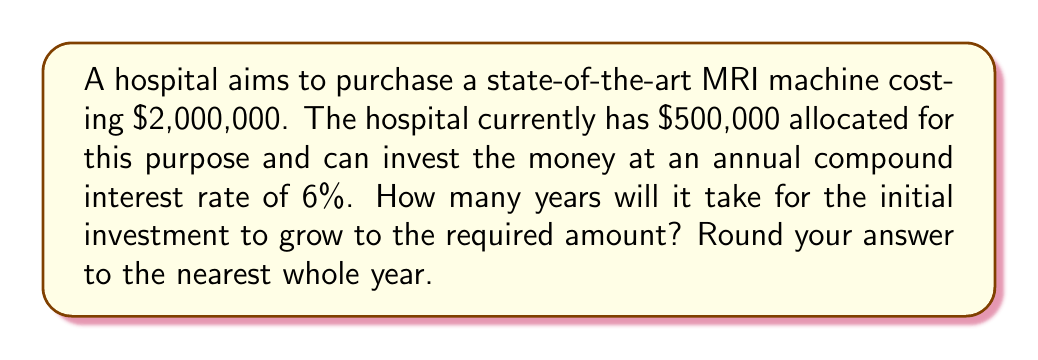Could you help me with this problem? Let's approach this step-by-step using the compound interest formula and logarithms:

1) The compound interest formula is:
   $A = P(1 + r)^t$
   Where:
   $A$ = Final amount
   $P$ = Principal (initial investment)
   $r$ = Annual interest rate (as a decimal)
   $t$ = Time in years

2) We know:
   $A = 2,000,000$
   $P = 500,000$
   $r = 0.06$ (6% as a decimal)

3) Substituting these values:
   $2,000,000 = 500,000(1 + 0.06)^t$

4) Divide both sides by 500,000:
   $4 = (1.06)^t$

5) Take the natural logarithm of both sides:
   $\ln(4) = \ln((1.06)^t)$

6) Using the logarithm property $\ln(a^b) = b\ln(a)$:
   $\ln(4) = t\ln(1.06)$

7) Solve for $t$:
   $t = \frac{\ln(4)}{\ln(1.06)}$

8) Calculate:
   $t = \frac{1.3862943611198906}{\0.058268908123975875} \approx 23.78$ years

9) Rounding to the nearest whole year:
   $t \approx 24$ years
Answer: 24 years 